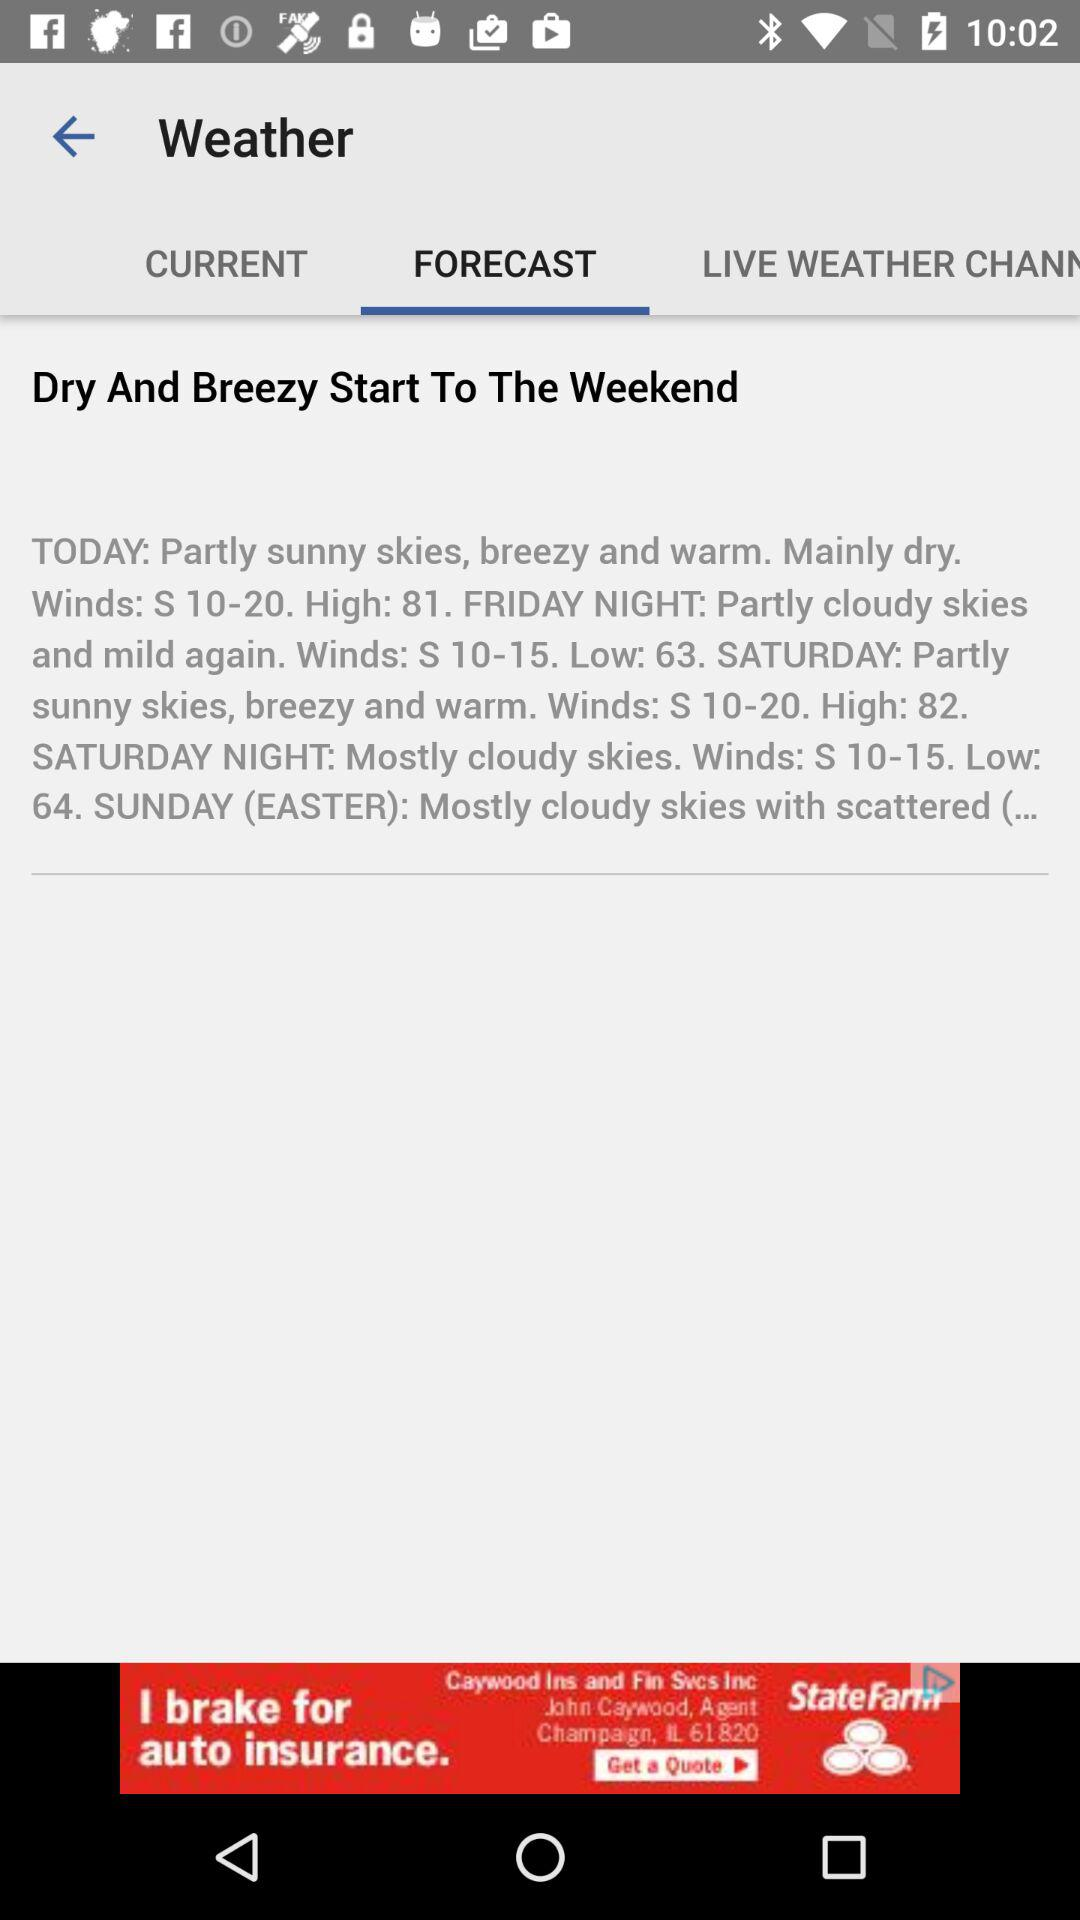How is the weather in Saturday? The weather on Saturday is partly sunny skies with breezy and warm winds. Winds from the south at 10-20 mph, with a high of 82. Saturday Night: Mostly cloudy skies. Winds from the south at 10-15 mph, with a low of 64. 